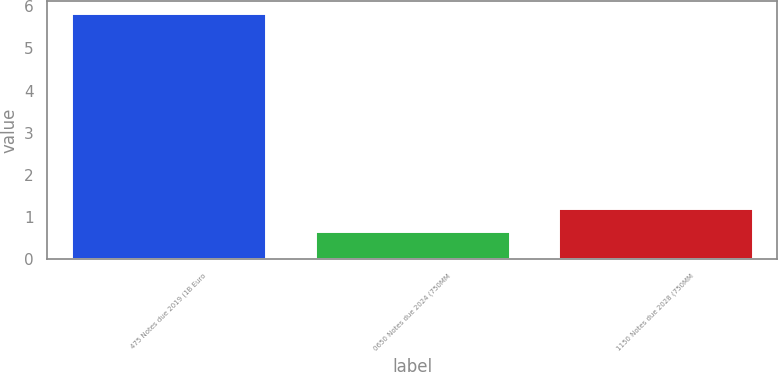Convert chart. <chart><loc_0><loc_0><loc_500><loc_500><bar_chart><fcel>475 Notes due 2019 (1B Euro<fcel>0650 Notes due 2024 (750MM<fcel>1150 Notes due 2028 (750MM<nl><fcel>5.83<fcel>0.68<fcel>1.21<nl></chart> 